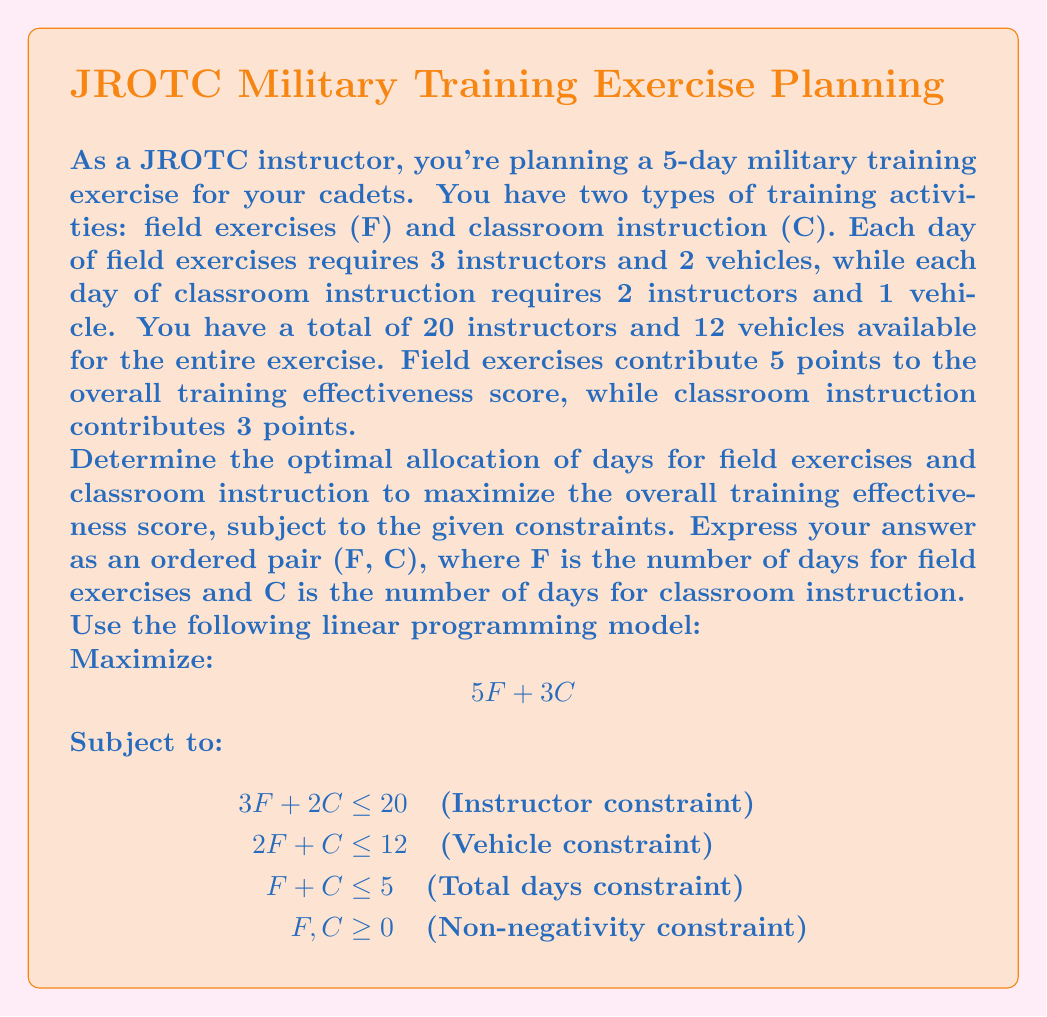Help me with this question. To solve this linear programming problem, we'll use the graphical method:

1) First, plot the constraints:
   - Instructor constraint: $3F + 2C = 20$
   - Vehicle constraint: $2F + C = 12$
   - Total days constraint: $F + C = 5$

2) The feasible region is the area that satisfies all constraints, including non-negativity.

3) The optimal solution will be at one of the corner points of the feasible region. Identify these points by finding the intersections of the constraint lines.

4) The relevant corner points are:
   (0, 5), (2, 3), (4, 1), and (3, 2)

5) Evaluate the objective function (5F + 3C) at each point:
   (0, 5): 5(0) + 3(5) = 15
   (2, 3): 5(2) + 3(3) = 19
   (4, 1): 5(4) + 3(1) = 23
   (3, 2): 5(3) + 3(2) = 21

6) The maximum value is 23, occurring at the point (4, 1).

Therefore, the optimal allocation is 4 days of field exercises and 1 day of classroom instruction.
Answer: (4, 1) 